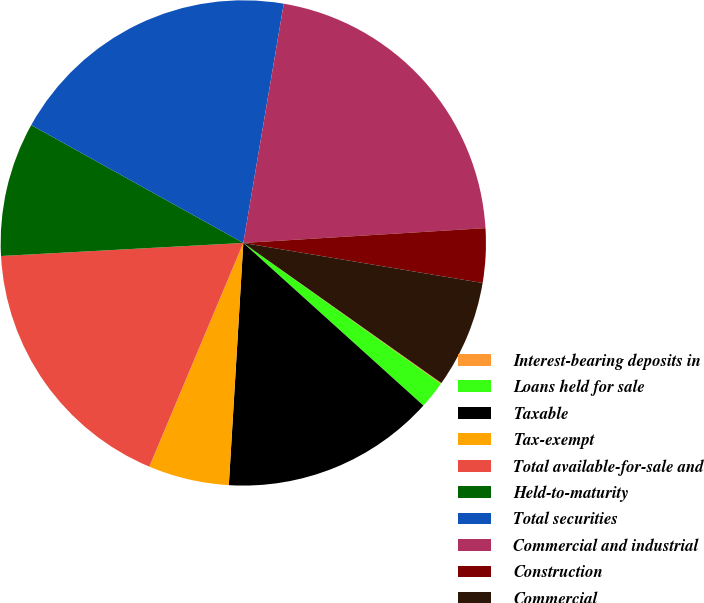Convert chart. <chart><loc_0><loc_0><loc_500><loc_500><pie_chart><fcel>Interest-bearing deposits in<fcel>Loans held for sale<fcel>Taxable<fcel>Tax-exempt<fcel>Total available-for-sale and<fcel>Held-to-maturity<fcel>Total securities<fcel>Commercial and industrial<fcel>Construction<fcel>Commercial<nl><fcel>0.06%<fcel>1.83%<fcel>14.26%<fcel>5.38%<fcel>17.81%<fcel>8.93%<fcel>19.59%<fcel>21.36%<fcel>3.61%<fcel>7.16%<nl></chart> 